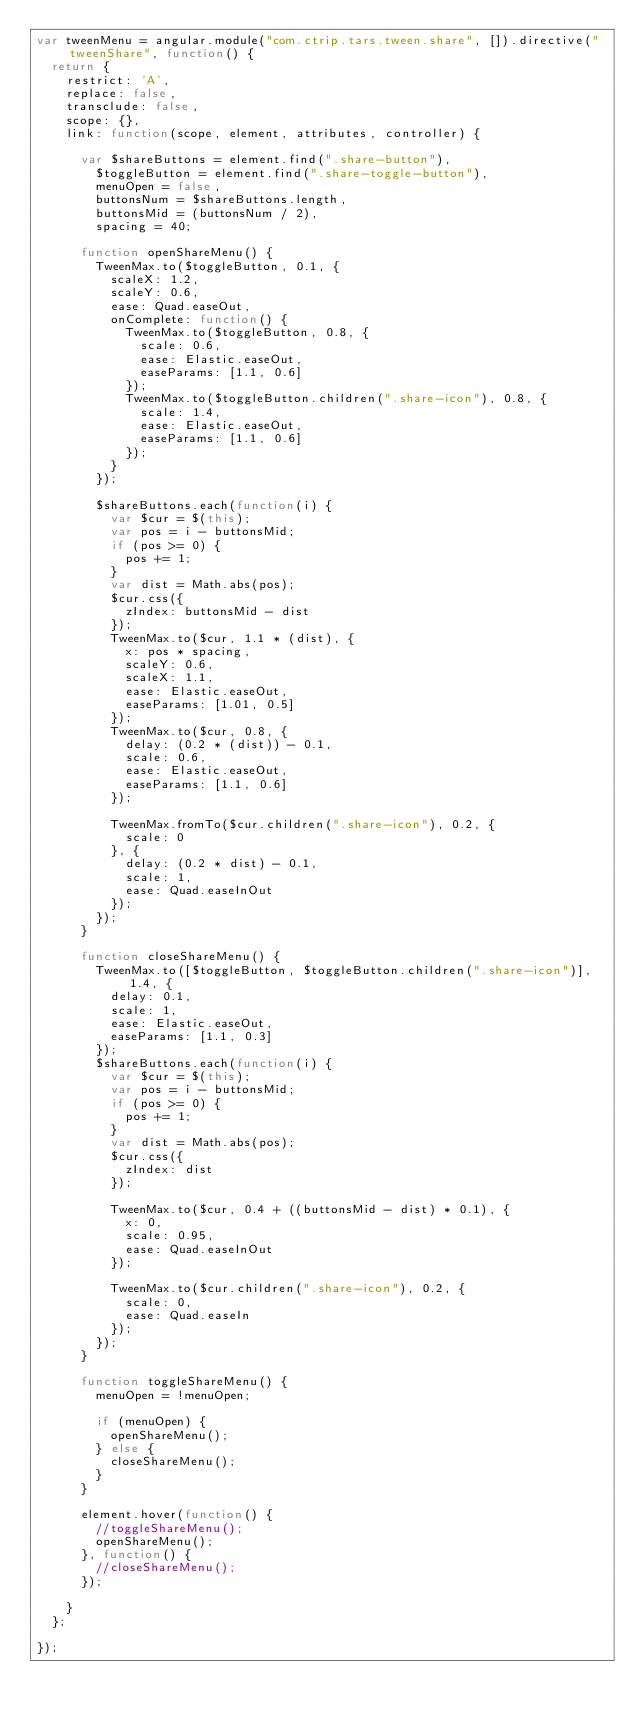Convert code to text. <code><loc_0><loc_0><loc_500><loc_500><_JavaScript_>var tweenMenu = angular.module("com.ctrip.tars.tween.share", []).directive("tweenShare", function() {
  return {
    restrict: 'A',
    replace: false,
    transclude: false,
    scope: {},
    link: function(scope, element, attributes, controller) {

      var $shareButtons = element.find(".share-button"),
        $toggleButton = element.find(".share-toggle-button"),
        menuOpen = false,
        buttonsNum = $shareButtons.length,
        buttonsMid = (buttonsNum / 2),
        spacing = 40;

      function openShareMenu() {
        TweenMax.to($toggleButton, 0.1, {
          scaleX: 1.2,
          scaleY: 0.6,
          ease: Quad.easeOut,
          onComplete: function() {
            TweenMax.to($toggleButton, 0.8, {
              scale: 0.6,
              ease: Elastic.easeOut,
              easeParams: [1.1, 0.6]
            });
            TweenMax.to($toggleButton.children(".share-icon"), 0.8, {
              scale: 1.4,
              ease: Elastic.easeOut,
              easeParams: [1.1, 0.6]
            });
          }
        });

        $shareButtons.each(function(i) {
          var $cur = $(this);
          var pos = i - buttonsMid;
          if (pos >= 0) {
            pos += 1;
          }
          var dist = Math.abs(pos);
          $cur.css({
            zIndex: buttonsMid - dist
          });
          TweenMax.to($cur, 1.1 * (dist), {
            x: pos * spacing,
            scaleY: 0.6,
            scaleX: 1.1,
            ease: Elastic.easeOut,
            easeParams: [1.01, 0.5]
          });
          TweenMax.to($cur, 0.8, {
            delay: (0.2 * (dist)) - 0.1,
            scale: 0.6,
            ease: Elastic.easeOut,
            easeParams: [1.1, 0.6]
          });

          TweenMax.fromTo($cur.children(".share-icon"), 0.2, {
            scale: 0
          }, {
            delay: (0.2 * dist) - 0.1,
            scale: 1,
            ease: Quad.easeInOut
          });
        });
      }

      function closeShareMenu() {
        TweenMax.to([$toggleButton, $toggleButton.children(".share-icon")], 1.4, {
          delay: 0.1,
          scale: 1,
          ease: Elastic.easeOut,
          easeParams: [1.1, 0.3]
        });
        $shareButtons.each(function(i) {
          var $cur = $(this);
          var pos = i - buttonsMid;
          if (pos >= 0) {
            pos += 1;
          }
          var dist = Math.abs(pos);
          $cur.css({
            zIndex: dist
          });

          TweenMax.to($cur, 0.4 + ((buttonsMid - dist) * 0.1), {
            x: 0,
            scale: 0.95,
            ease: Quad.easeInOut
          });

          TweenMax.to($cur.children(".share-icon"), 0.2, {
            scale: 0,
            ease: Quad.easeIn
          });
        });
      }

      function toggleShareMenu() {
        menuOpen = !menuOpen;

        if (menuOpen) {
          openShareMenu();
        } else {
          closeShareMenu();
        }
      }

      element.hover(function() {
        //toggleShareMenu();
        openShareMenu();
      }, function() {
        //closeShareMenu();
      });

    }
  };

});

</code> 